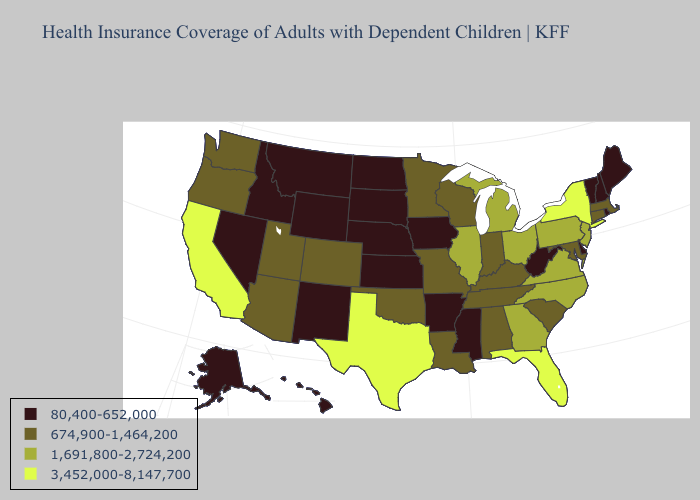What is the value of Ohio?
Answer briefly. 1,691,800-2,724,200. What is the highest value in the South ?
Keep it brief. 3,452,000-8,147,700. Name the states that have a value in the range 3,452,000-8,147,700?
Give a very brief answer. California, Florida, New York, Texas. Which states have the lowest value in the South?
Write a very short answer. Arkansas, Delaware, Mississippi, West Virginia. Name the states that have a value in the range 674,900-1,464,200?
Keep it brief. Alabama, Arizona, Colorado, Connecticut, Indiana, Kentucky, Louisiana, Maryland, Massachusetts, Minnesota, Missouri, Oklahoma, Oregon, South Carolina, Tennessee, Utah, Washington, Wisconsin. Among the states that border Utah , which have the lowest value?
Concise answer only. Idaho, Nevada, New Mexico, Wyoming. Does New Mexico have a lower value than New York?
Short answer required. Yes. What is the value of South Carolina?
Be succinct. 674,900-1,464,200. Does the first symbol in the legend represent the smallest category?
Be succinct. Yes. Does the first symbol in the legend represent the smallest category?
Answer briefly. Yes. Name the states that have a value in the range 1,691,800-2,724,200?
Give a very brief answer. Georgia, Illinois, Michigan, New Jersey, North Carolina, Ohio, Pennsylvania, Virginia. What is the highest value in the West ?
Write a very short answer. 3,452,000-8,147,700. What is the highest value in states that border Georgia?
Be succinct. 3,452,000-8,147,700. How many symbols are there in the legend?
Be succinct. 4. Name the states that have a value in the range 1,691,800-2,724,200?
Be succinct. Georgia, Illinois, Michigan, New Jersey, North Carolina, Ohio, Pennsylvania, Virginia. 